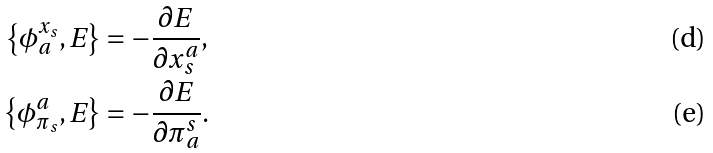Convert formula to latex. <formula><loc_0><loc_0><loc_500><loc_500>\left \{ \phi _ { a } ^ { x _ { s } } , E \right \} & = - \frac { \partial E } { \partial x _ { s } ^ { a } } , \\ \left \{ \phi _ { \pi _ { s } } ^ { a } , E \right \} & = - \frac { \partial E } { \partial \pi _ { a } ^ { s } } .</formula> 